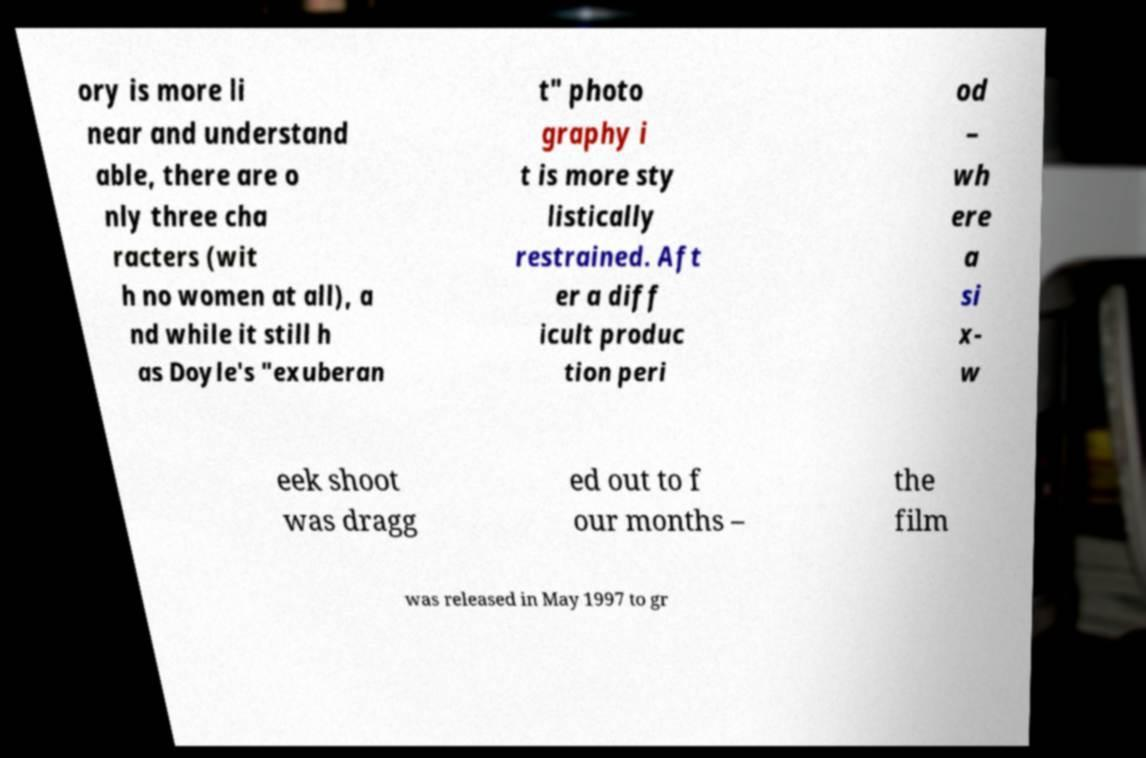I need the written content from this picture converted into text. Can you do that? ory is more li near and understand able, there are o nly three cha racters (wit h no women at all), a nd while it still h as Doyle's "exuberan t" photo graphy i t is more sty listically restrained. Aft er a diff icult produc tion peri od – wh ere a si x- w eek shoot was dragg ed out to f our months – the film was released in May 1997 to gr 